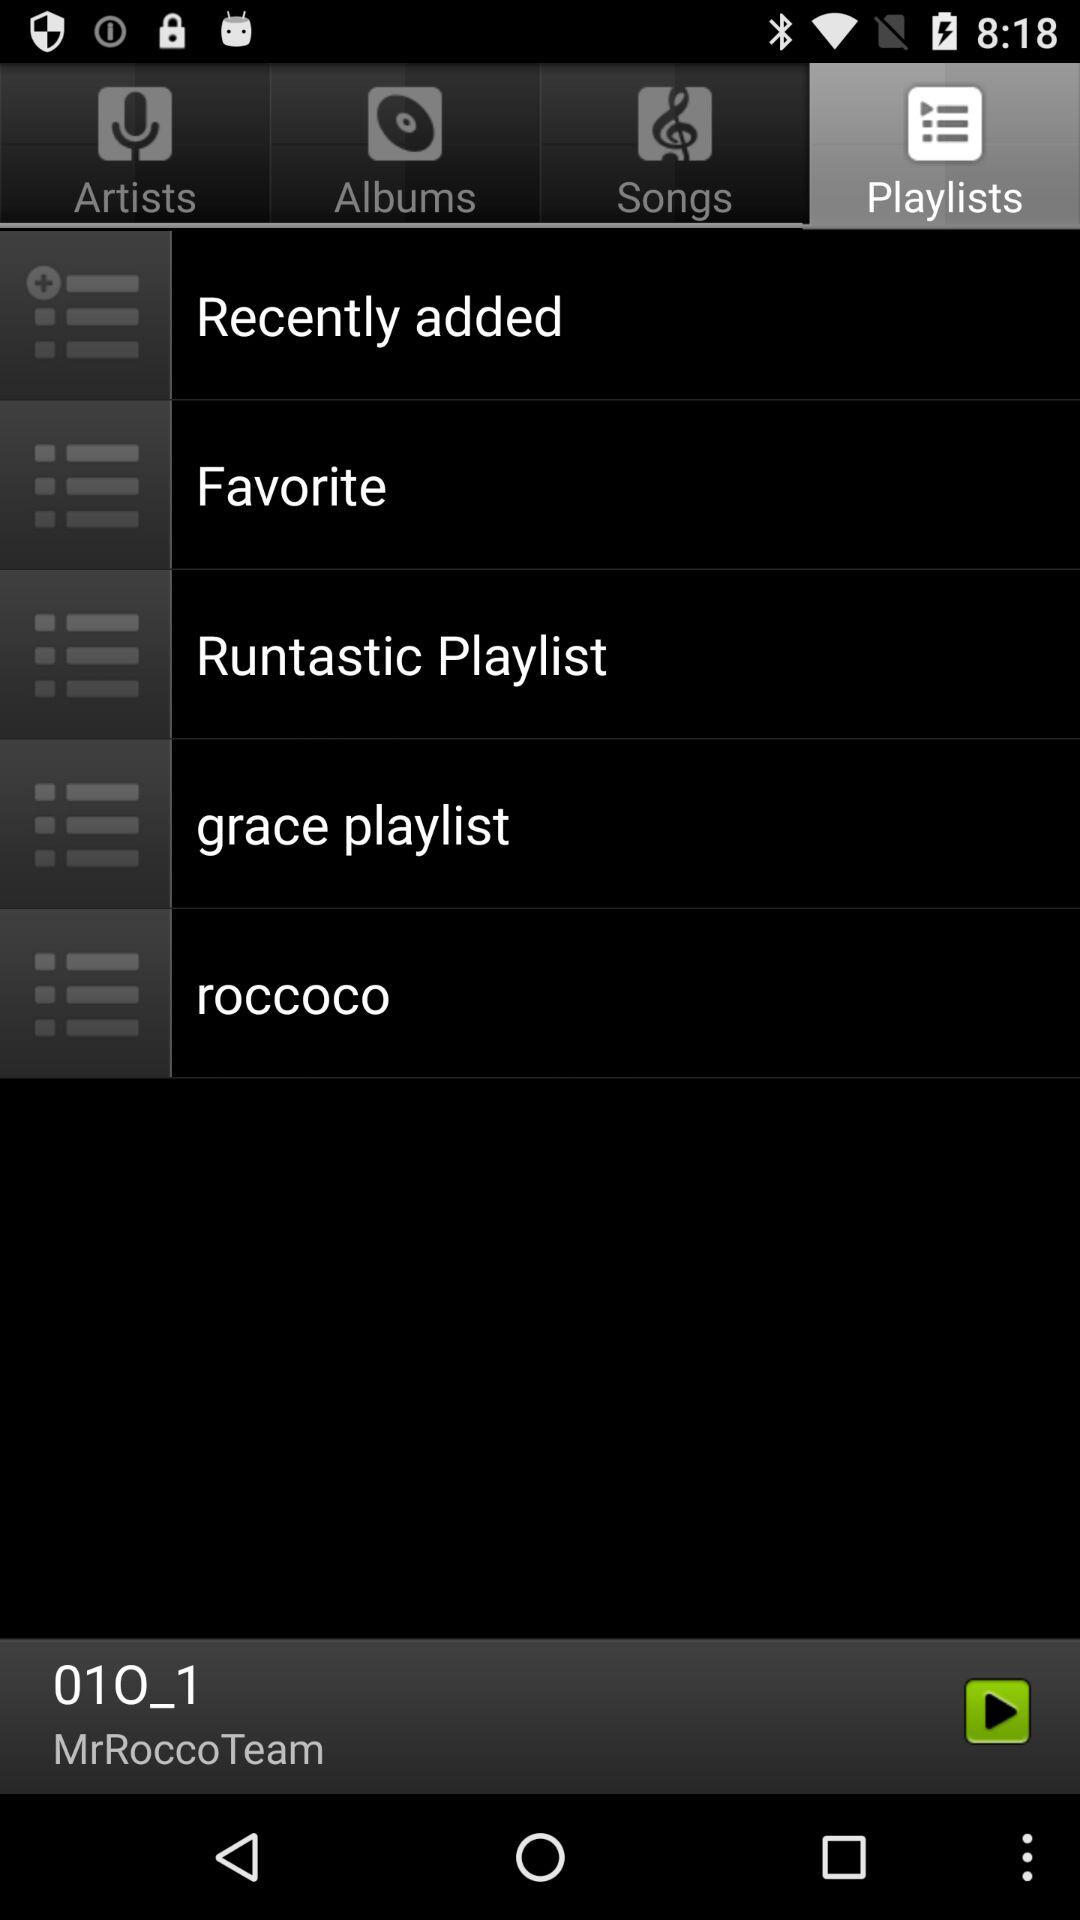What is the name of the audio that is played? The name of the audio is 010_1. 